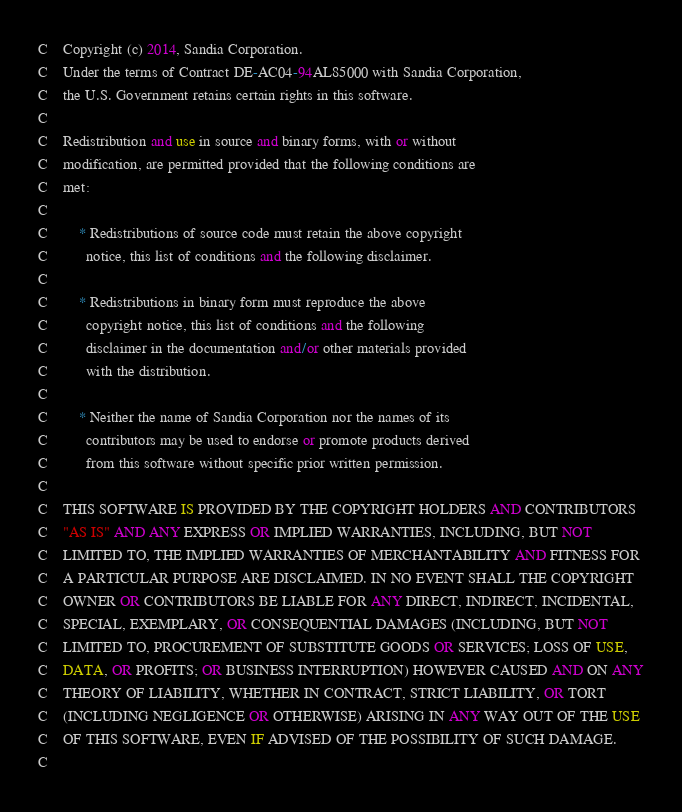<code> <loc_0><loc_0><loc_500><loc_500><_FORTRAN_>C    Copyright (c) 2014, Sandia Corporation.
C    Under the terms of Contract DE-AC04-94AL85000 with Sandia Corporation,
C    the U.S. Government retains certain rights in this software.
C    
C    Redistribution and use in source and binary forms, with or without
C    modification, are permitted provided that the following conditions are
C    met:
C    
C        * Redistributions of source code must retain the above copyright
C          notice, this list of conditions and the following disclaimer.
C    
C        * Redistributions in binary form must reproduce the above
C          copyright notice, this list of conditions and the following
C          disclaimer in the documentation and/or other materials provided
C          with the distribution.
C    
C        * Neither the name of Sandia Corporation nor the names of its
C          contributors may be used to endorse or promote products derived
C          from this software without specific prior written permission.
C    
C    THIS SOFTWARE IS PROVIDED BY THE COPYRIGHT HOLDERS AND CONTRIBUTORS
C    "AS IS" AND ANY EXPRESS OR IMPLIED WARRANTIES, INCLUDING, BUT NOT
C    LIMITED TO, THE IMPLIED WARRANTIES OF MERCHANTABILITY AND FITNESS FOR
C    A PARTICULAR PURPOSE ARE DISCLAIMED. IN NO EVENT SHALL THE COPYRIGHT
C    OWNER OR CONTRIBUTORS BE LIABLE FOR ANY DIRECT, INDIRECT, INCIDENTAL,
C    SPECIAL, EXEMPLARY, OR CONSEQUENTIAL DAMAGES (INCLUDING, BUT NOT
C    LIMITED TO, PROCUREMENT OF SUBSTITUTE GOODS OR SERVICES; LOSS OF USE,
C    DATA, OR PROFITS; OR BUSINESS INTERRUPTION) HOWEVER CAUSED AND ON ANY
C    THEORY OF LIABILITY, WHETHER IN CONTRACT, STRICT LIABILITY, OR TORT
C    (INCLUDING NEGLIGENCE OR OTHERWISE) ARISING IN ANY WAY OUT OF THE USE
C    OF THIS SOFTWARE, EVEN IF ADVISED OF THE POSSIBILITY OF SUCH DAMAGE.
C    
</code> 